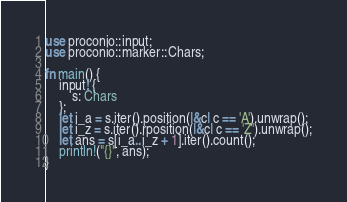Convert code to text. <code><loc_0><loc_0><loc_500><loc_500><_Rust_>use proconio::input;
use proconio::marker::Chars;

fn main() {
    input! {
        s: Chars
    };
    let i_a = s.iter().position(|&c| c == 'A').unwrap();
    let i_z = s.iter().rposition(|&c| c == 'Z').unwrap();
    let ans = s[i_a..i_z + 1].iter().count();
    println!("{}", ans);
}
</code> 